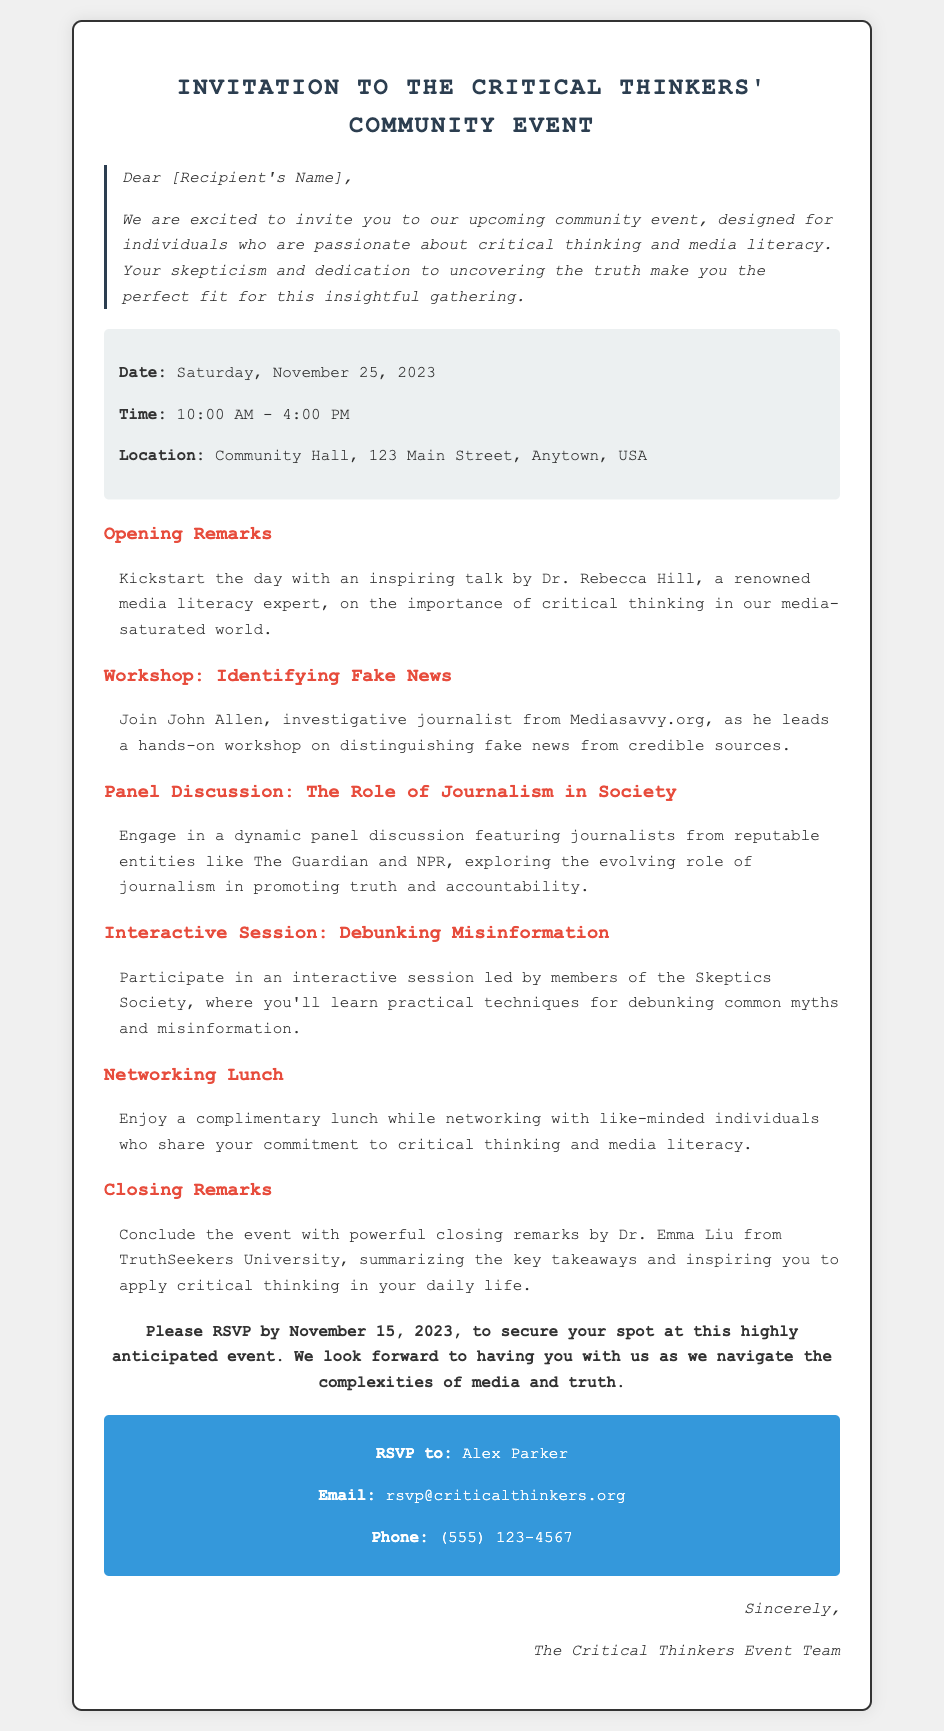What is the date of the event? The date of the event is explicitly mentioned in the document.
Answer: Saturday, November 25, 2023 Who is leading the workshop on identifying fake news? The document names John Allen as the leader of that workshop.
Answer: John Allen What is the primary focus of Dr. Rebecca Hill's talk? The document highlights the importance of critical thinking in Dr. Hill's opening remarks.
Answer: Importance of critical thinking What type of session is led by the members of the Skeptics Society? The document refers to this session as “Interactive Session: Debunking Misinformation.”
Answer: Interactive Session: Debunking Misinformation When is the RSVP deadline? The RSVP deadline is specifically stated in the invitation.
Answer: November 15, 2023 What is the location of the community event? The document provides the address for the event location.
Answer: Community Hall, 123 Main Street, Anytown, USA Who will provide the closing remarks? The invitation specifies that Dr. Emma Liu will provide the closing remarks of the event.
Answer: Dr. Emma Liu What is included during the networking lunch? The document states that attendees will enjoy a complimentary lunch during this time.
Answer: Complimentary lunch What is the event's main theme? The overall theme of the event is explicitly stated in the introduction.
Answer: Critical thinking and media literacy 